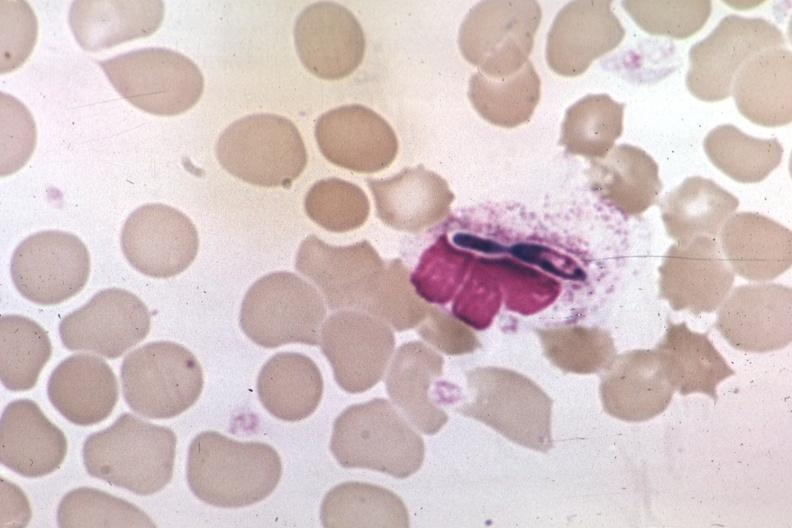does this image show wrights in macrophage?
Answer the question using a single word or phrase. Yes 